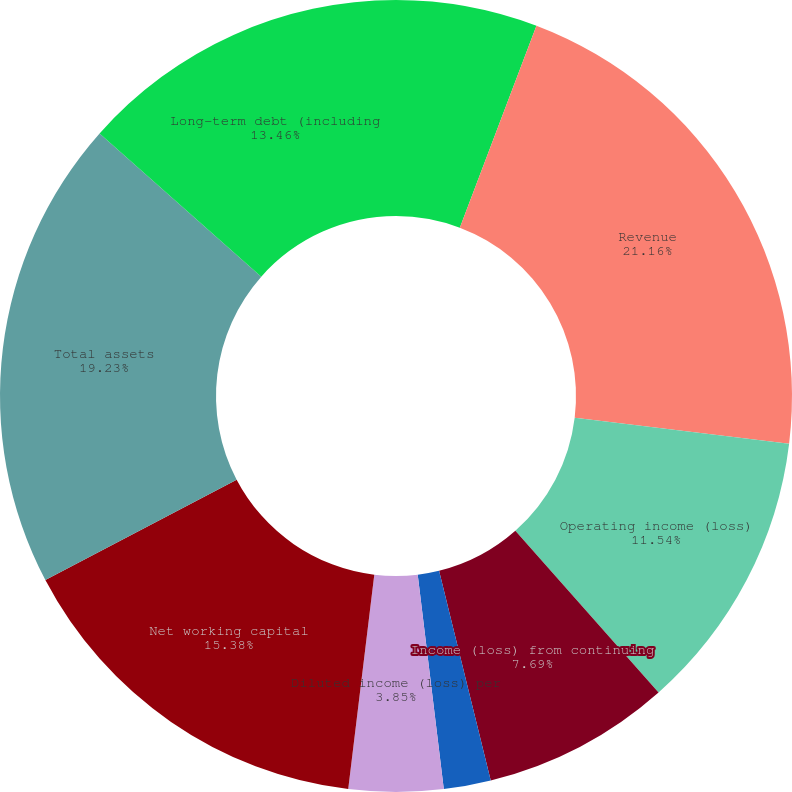Convert chart. <chart><loc_0><loc_0><loc_500><loc_500><pie_chart><fcel>Millions of dollars except per<fcel>Revenue<fcel>Operating income (loss)<fcel>Income (loss) from continuing<fcel>Basic income (loss) per share<fcel>Diluted income (loss) per<fcel>Cash dividends per share<fcel>Net working capital<fcel>Total assets<fcel>Long-term debt (including<nl><fcel>5.77%<fcel>21.15%<fcel>11.54%<fcel>7.69%<fcel>1.92%<fcel>3.85%<fcel>0.0%<fcel>15.38%<fcel>19.23%<fcel>13.46%<nl></chart> 